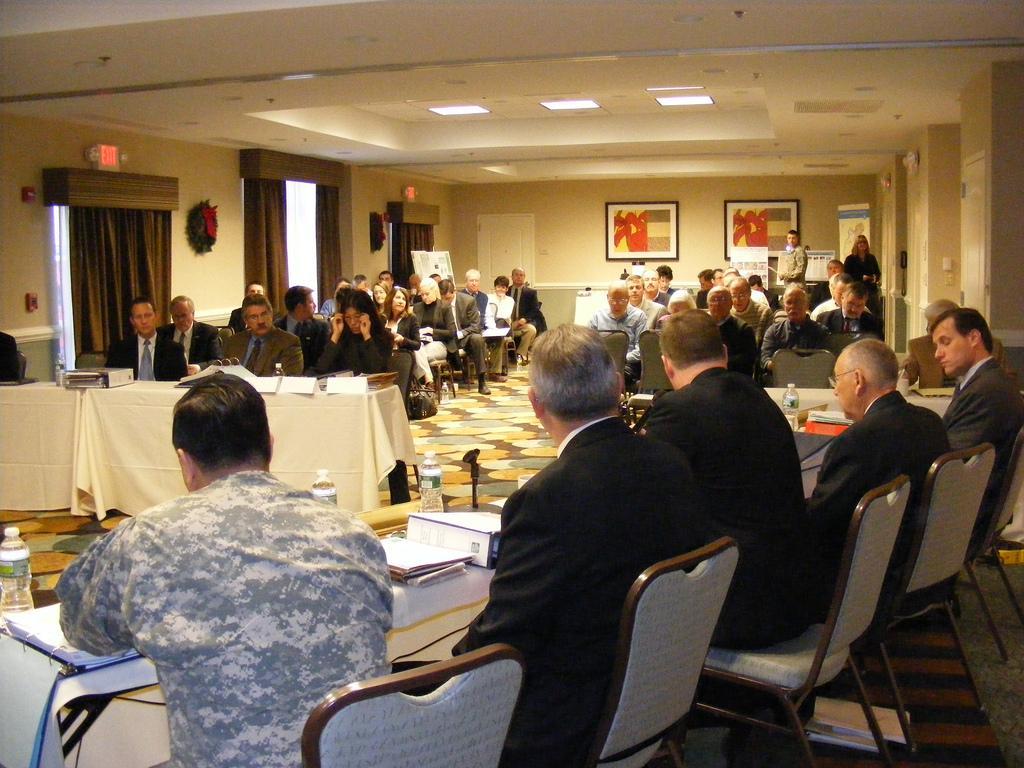Can you describe this image briefly? Here we can see a group of people are sitting on the chair, and in front here is the table and books and some objects on it, and here is the wall and photo frames on it, and at above here is the light. 